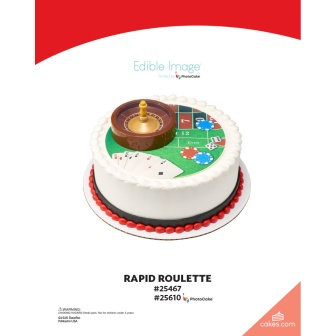Could you explain the significance of the design elements in this cake? The cake’s design elements are meticulously chosen to create a casino-themed visual impact. The central roulette wheel, crafted with fondant, is rich in detail and serves as the focal point. Its realistic colors and numbers echo the roulette game from casinos, evoking excitement and anticipation. The black and red border complements the roulette wheel, maintaining the color scheme associated with gambling and casinos. This thoughtfully designed cake could be the centerpiece for a casino-themed event, adding an element of sophistication and fun. 